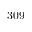Convert formula to latex. <formula><loc_0><loc_0><loc_500><loc_500>3 0 9</formula> 